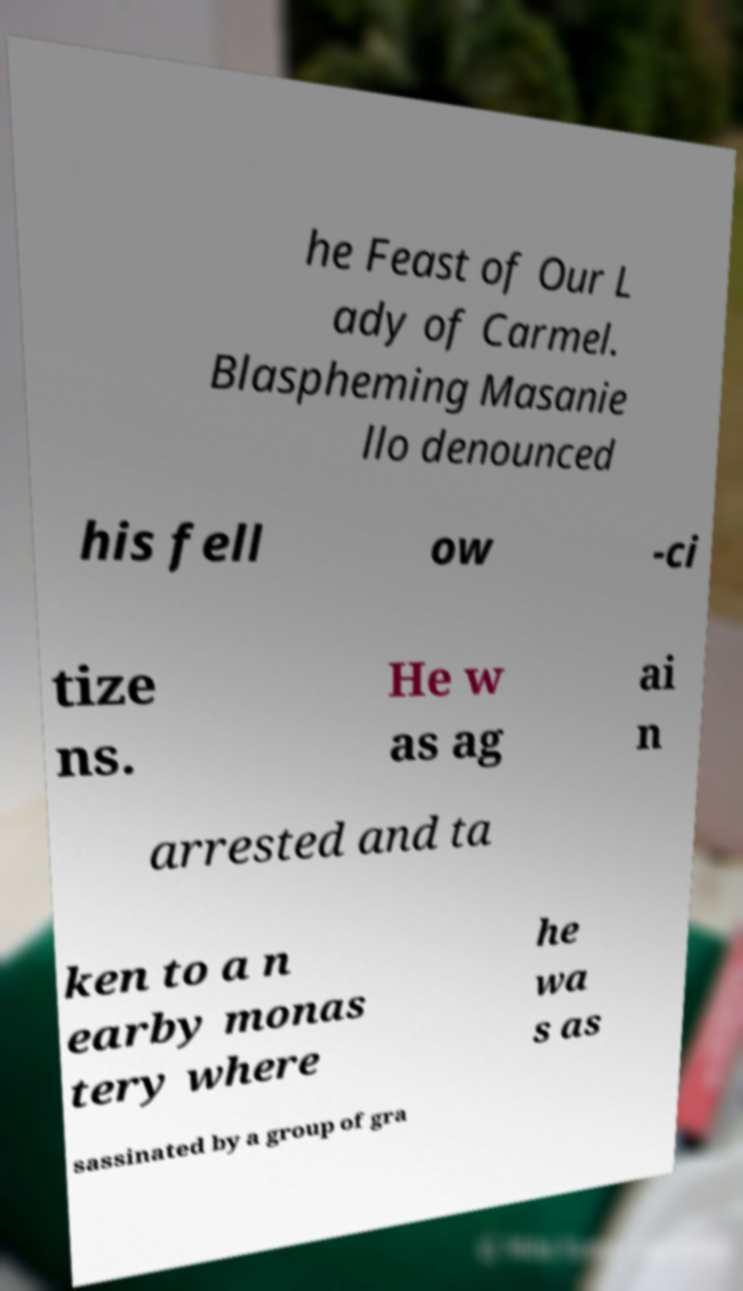There's text embedded in this image that I need extracted. Can you transcribe it verbatim? he Feast of Our L ady of Carmel. Blaspheming Masanie llo denounced his fell ow -ci tize ns. He w as ag ai n arrested and ta ken to a n earby monas tery where he wa s as sassinated by a group of gra 